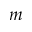<formula> <loc_0><loc_0><loc_500><loc_500>m</formula> 